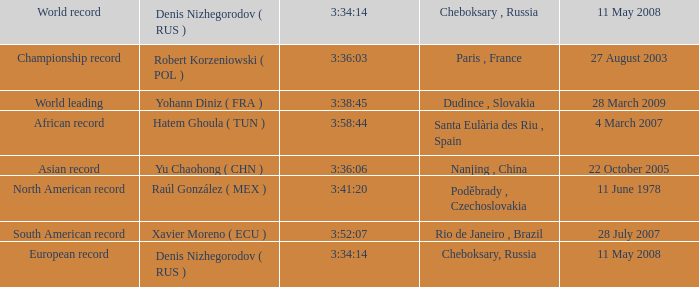Parse the full table. {'header': ['World record', 'Denis Nizhegorodov ( RUS )', '3:34:14', 'Cheboksary , Russia', '11 May 2008'], 'rows': [['Championship record', 'Robert Korzeniowski ( POL )', '3:36:03', 'Paris , France', '27 August 2003'], ['World leading', 'Yohann Diniz ( FRA )', '3:38:45', 'Dudince , Slovakia', '28 March 2009'], ['African record', 'Hatem Ghoula ( TUN )', '3:58:44', 'Santa Eulària des Riu , Spain', '4 March 2007'], ['Asian record', 'Yu Chaohong ( CHN )', '3:36:06', 'Nanjing , China', '22 October 2005'], ['North American record', 'Raúl González ( MEX )', '3:41:20', 'Poděbrady , Czechoslovakia', '11 June 1978'], ['South American record', 'Xavier Moreno ( ECU )', '3:52:07', 'Rio de Janeiro , Brazil', '28 July 2007'], ['European record', 'Denis Nizhegorodov ( RUS )', '3:34:14', 'Cheboksary, Russia', '11 May 2008']]} With 3:41:20 as 3:34:14, what is the meaning of cheboksary, russia? Poděbrady , Czechoslovakia. 